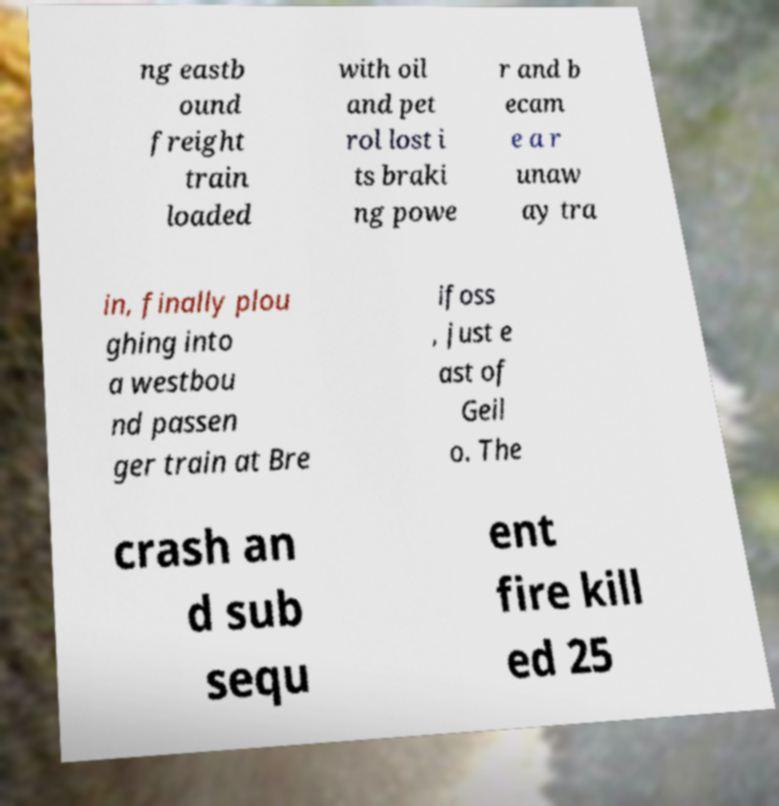There's text embedded in this image that I need extracted. Can you transcribe it verbatim? ng eastb ound freight train loaded with oil and pet rol lost i ts braki ng powe r and b ecam e a r unaw ay tra in, finally plou ghing into a westbou nd passen ger train at Bre ifoss , just e ast of Geil o. The crash an d sub sequ ent fire kill ed 25 